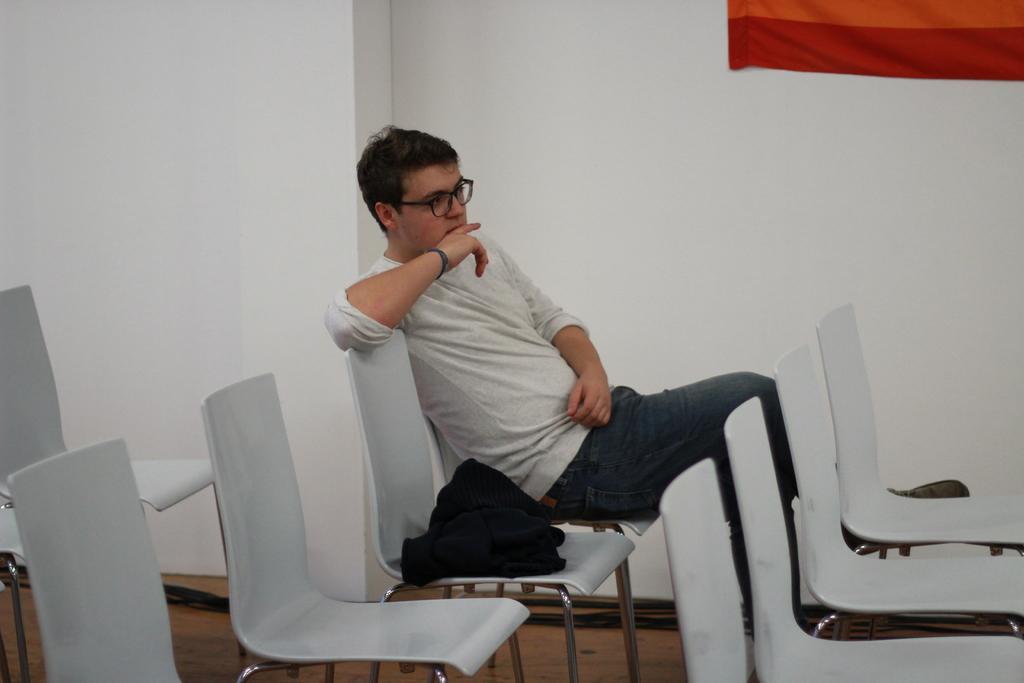In one or two sentences, can you explain what this image depicts? There is a room. The person is sitting in a chair. He's wearing a spectacle. 